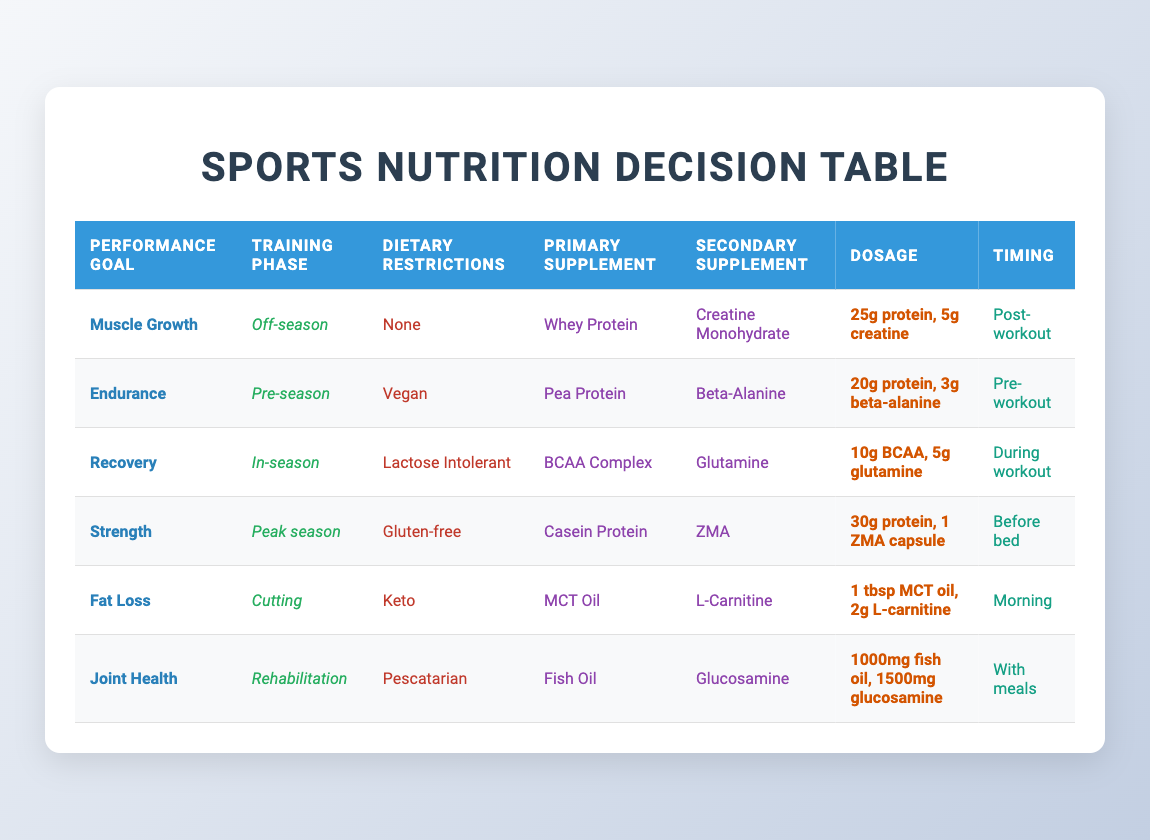What is the primary supplement recommended for Muscle Growth in the Off-season? The table shows that for the performance goal of Muscle Growth during the Off-season, the primary supplement is Whey Protein.
Answer: Whey Protein Which supplement is suggested as a Secondary Supplement for those focusing on Endurance in the Pre-season? For the Endurance performance goal in the Pre-season, the table indicates the Secondary Supplement is Beta-Alanine.
Answer: Beta-Alanine Is the dosage for Recovery during In-season higher than the dosage recommended for Muscle Growth in the Off-season? The Recovery dosage is 10g BCAA and 5g glutamine, totaling 15g, while the Muscle Growth dosage is 25g protein and 5g creatine, totaling 30g. Since 30g is greater than 15g, the answer is yes.
Answer: Yes What is the timing for taking the Primary Supplement for those with a Dietary Restriction of being Lactose Intolerant? The table specifies that during the In-season for Lactose Intolerance, the timing for the Primary Supplement (BCAA Complex) is During workout.
Answer: During workout How many grams of protein do you take for Fat Loss during the Cutting phase? The table shows that for Fat Loss in the Cutting phase, 1 tablespoon of MCT oil is used as the Primary Supplement, which does not contain protein. The Secondary Supplement (L-Carnitine) also does not indicate any protein content, so the answer is 0 grams.
Answer: 0 grams Which training phase recommends Fish Oil for Joint Health? According to the table, the Joint Health goal during the Rehabilitation training phase indicates Fish Oil as the Primary Supplement.
Answer: Rehabilitation What is the average protein dosage recommended for Muscle Growth and Strength training? The dosage for Muscle Growth is 25g and for Strength it is 30g. The average is calculated as (25 + 30) / 2 = 27.5g.
Answer: 27.5g Are both the Primary and Secondary Supplements for muscle growth lactose-free? The table indicates that the Primary Supplement is Whey Protein. Whey Protein contains lactose, so the answer is no.
Answer: No In which training phase is MCT Oil suggested as a Primary Supplement? As per the table, MCT Oil is recommended during the Cutting phase, specifically for the Fat Loss performance goal.
Answer: Cutting 